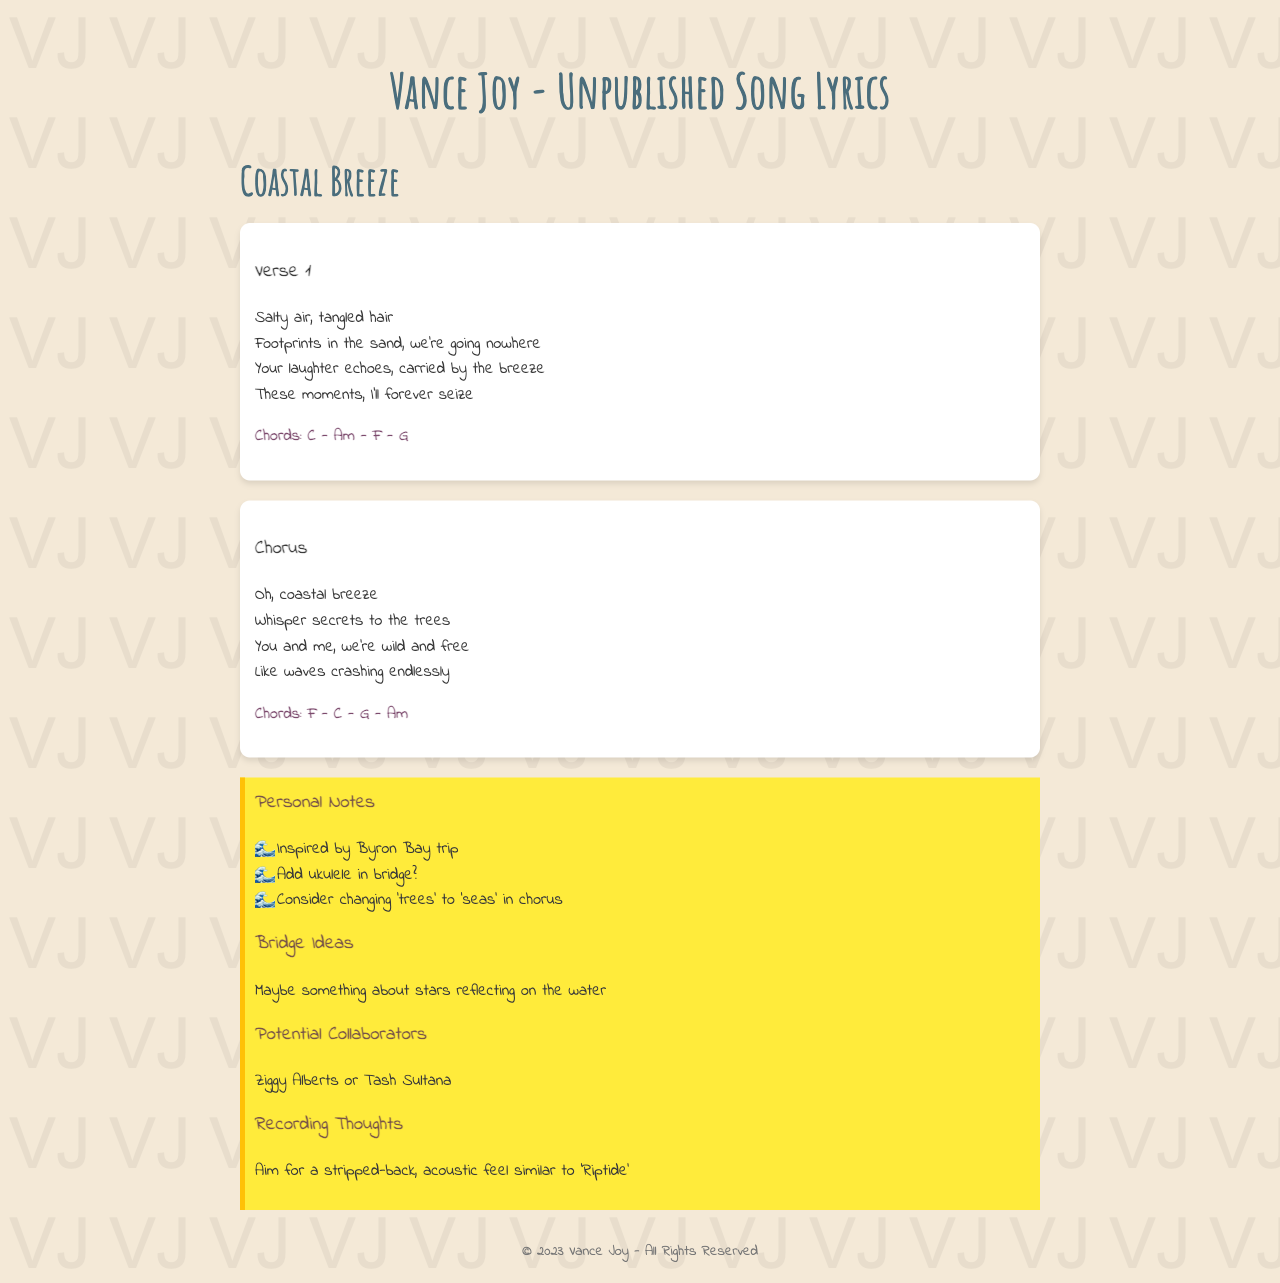What is the title of the song? The title of the song is presented in the main heading of the document.
Answer: Coastal Breeze Who is the artist of the song? The artist is mentioned in the title of the document.
Answer: Vance Joy What chords are used in the verse? The chords used in the verse are included in the relevant section under "Chords".
Answer: C - Am - F - G What inspired the song? The inspiration for the song is listed in the personal notes section.
Answer: Byron Bay trip How many notes are in the personal notes section? The personal notes contain a list of specific items, and there are four listed notes.
Answer: 4 What is suggested to add in the bridge? The document contains a question regarding the addition of the ukulele in the bridge section.
Answer: Ukulele What is a potential collaborator mentioned? The document lists potential collaborators in a specific section, naming one of them.
Answer: Ziggy Alberts What should the recording aim for? The recording thoughts specify the desired style for the song.
Answer: Stripped-back, acoustic feel 